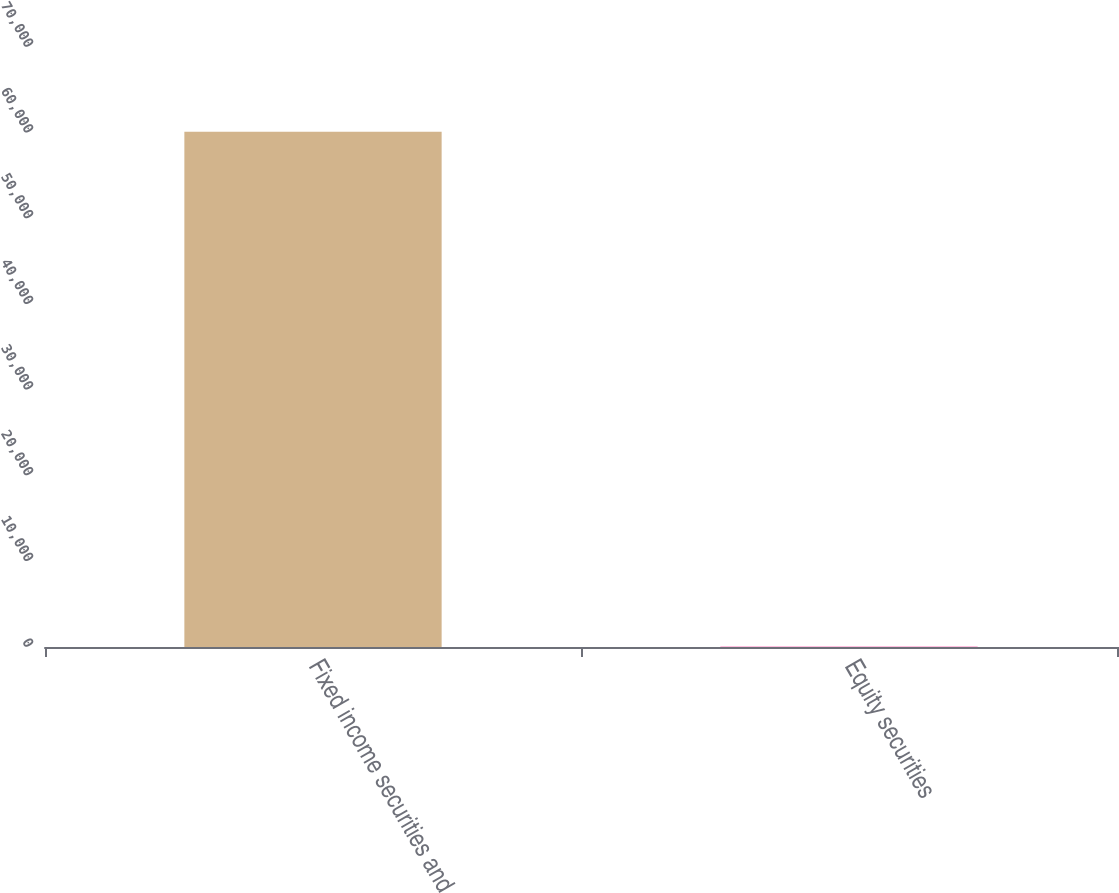<chart> <loc_0><loc_0><loc_500><loc_500><bar_chart><fcel>Fixed income securities and<fcel>Equity securities<nl><fcel>60100<fcel>40<nl></chart> 